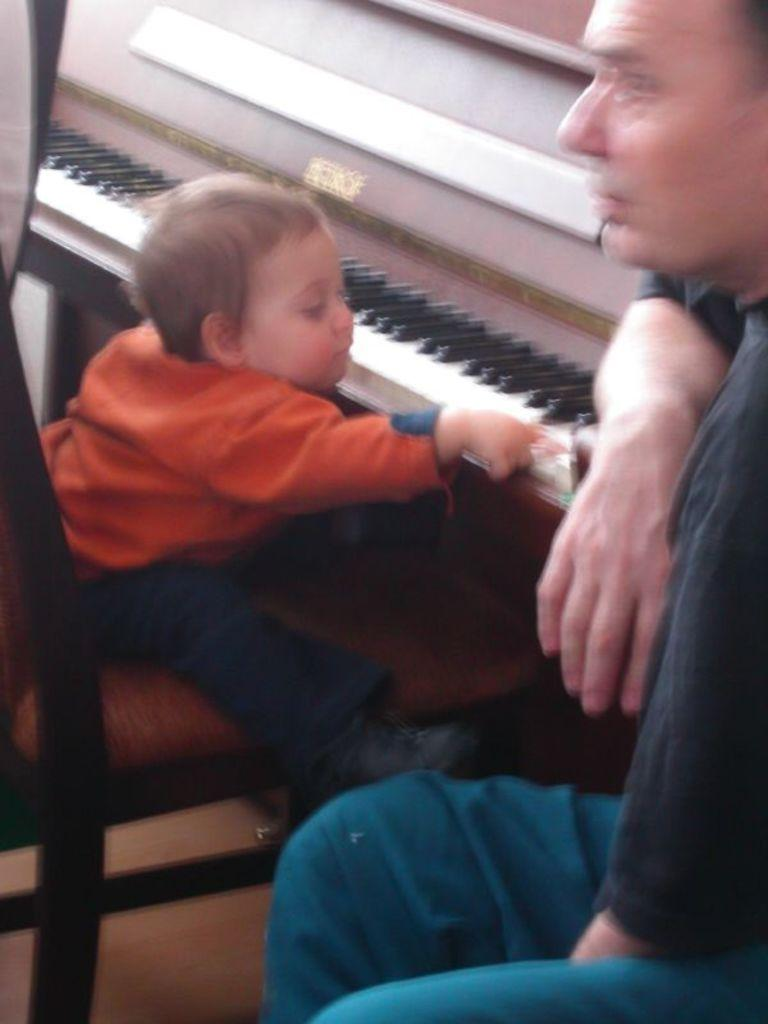What is the main subject of the image? The main subject of the image is a kid. What is the kid doing in the image? The kid is sitting in a chair and playing with a piano. Is there anyone else in the image? Yes, there is a person beside the kid. What type of books can be seen on the piano in the image? There are no books visible on the piano in the image. 